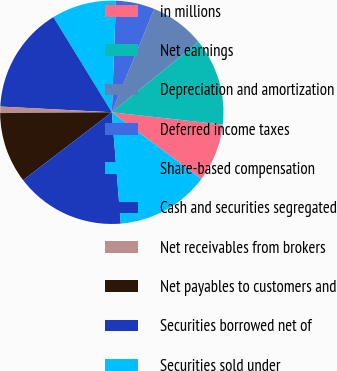<chart> <loc_0><loc_0><loc_500><loc_500><pie_chart><fcel>in millions<fcel>Net earnings<fcel>Depreciation and amortization<fcel>Deferred income taxes<fcel>Share-based compensation<fcel>Cash and securities segregated<fcel>Net receivables from brokers<fcel>Net payables to customers and<fcel>Securities borrowed net of<fcel>Securities sold under<nl><fcel>8.41%<fcel>12.62%<fcel>7.94%<fcel>5.61%<fcel>9.35%<fcel>15.42%<fcel>0.93%<fcel>10.28%<fcel>15.89%<fcel>13.55%<nl></chart> 